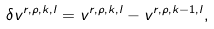Convert formula to latex. <formula><loc_0><loc_0><loc_500><loc_500>\delta v ^ { r , \rho , k , l } = v ^ { r , \rho , k , l } - v ^ { r , \rho , k - 1 , l } ,</formula> 